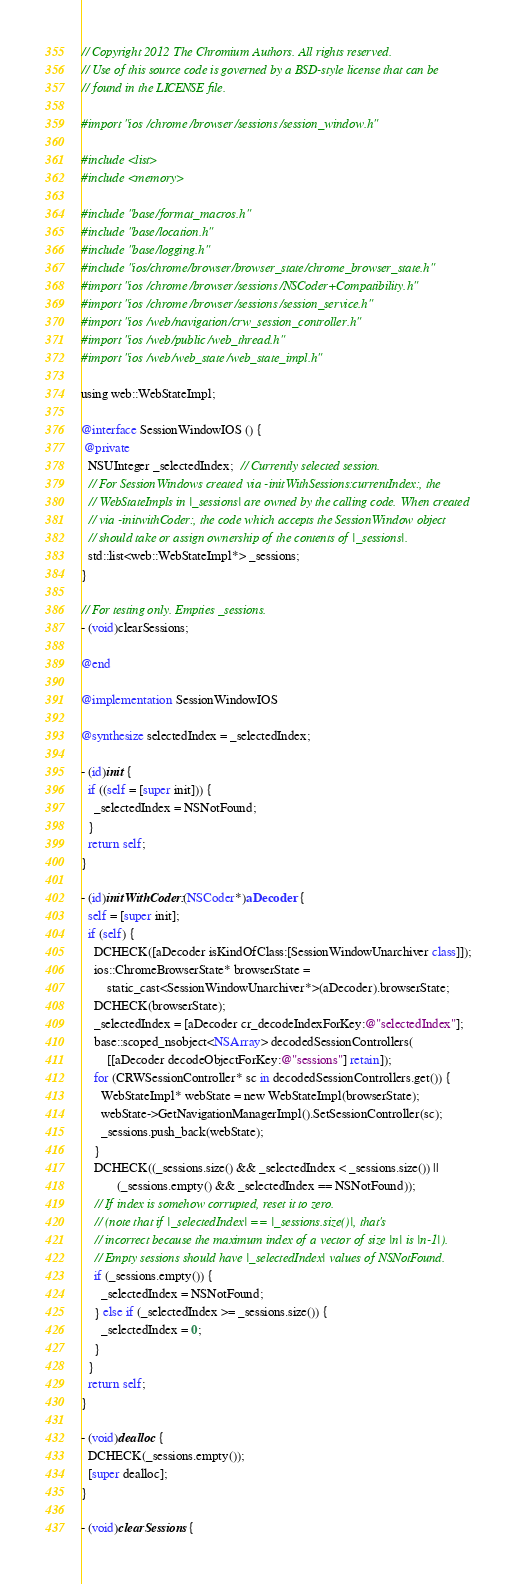<code> <loc_0><loc_0><loc_500><loc_500><_ObjectiveC_>// Copyright 2012 The Chromium Authors. All rights reserved.
// Use of this source code is governed by a BSD-style license that can be
// found in the LICENSE file.

#import "ios/chrome/browser/sessions/session_window.h"

#include <list>
#include <memory>

#include "base/format_macros.h"
#include "base/location.h"
#include "base/logging.h"
#include "ios/chrome/browser/browser_state/chrome_browser_state.h"
#import "ios/chrome/browser/sessions/NSCoder+Compatibility.h"
#import "ios/chrome/browser/sessions/session_service.h"
#import "ios/web/navigation/crw_session_controller.h"
#import "ios/web/public/web_thread.h"
#import "ios/web/web_state/web_state_impl.h"

using web::WebStateImpl;

@interface SessionWindowIOS () {
 @private
  NSUInteger _selectedIndex;  // Currently selected session.
  // For SessionWindows created via -initWithSessions:currentIndex:, the
  // WebStateImpls in |_sessions| are owned by the calling code. When created
  // via -initwithCoder:, the code which accepts the SessionWindow object
  // should take or assign ownership of the contents of |_sessions|.
  std::list<web::WebStateImpl*> _sessions;
}

// For testing only. Empties _sessions.
- (void)clearSessions;

@end

@implementation SessionWindowIOS

@synthesize selectedIndex = _selectedIndex;

- (id)init {
  if ((self = [super init])) {
    _selectedIndex = NSNotFound;
  }
  return self;
}

- (id)initWithCoder:(NSCoder*)aDecoder {
  self = [super init];
  if (self) {
    DCHECK([aDecoder isKindOfClass:[SessionWindowUnarchiver class]]);
    ios::ChromeBrowserState* browserState =
        static_cast<SessionWindowUnarchiver*>(aDecoder).browserState;
    DCHECK(browserState);
    _selectedIndex = [aDecoder cr_decodeIndexForKey:@"selectedIndex"];
    base::scoped_nsobject<NSArray> decodedSessionControllers(
        [[aDecoder decodeObjectForKey:@"sessions"] retain]);
    for (CRWSessionController* sc in decodedSessionControllers.get()) {
      WebStateImpl* webState = new WebStateImpl(browserState);
      webState->GetNavigationManagerImpl().SetSessionController(sc);
      _sessions.push_back(webState);
    }
    DCHECK((_sessions.size() && _selectedIndex < _sessions.size()) ||
           (_sessions.empty() && _selectedIndex == NSNotFound));
    // If index is somehow corrupted, reset it to zero.
    // (note that if |_selectedIndex| == |_sessions.size()|, that's
    // incorrect because the maximum index of a vector of size |n| is |n-1|).
    // Empty sessions should have |_selectedIndex| values of NSNotFound.
    if (_sessions.empty()) {
      _selectedIndex = NSNotFound;
    } else if (_selectedIndex >= _sessions.size()) {
      _selectedIndex = 0;
    }
  }
  return self;
}

- (void)dealloc {
  DCHECK(_sessions.empty());
  [super dealloc];
}

- (void)clearSessions {</code> 